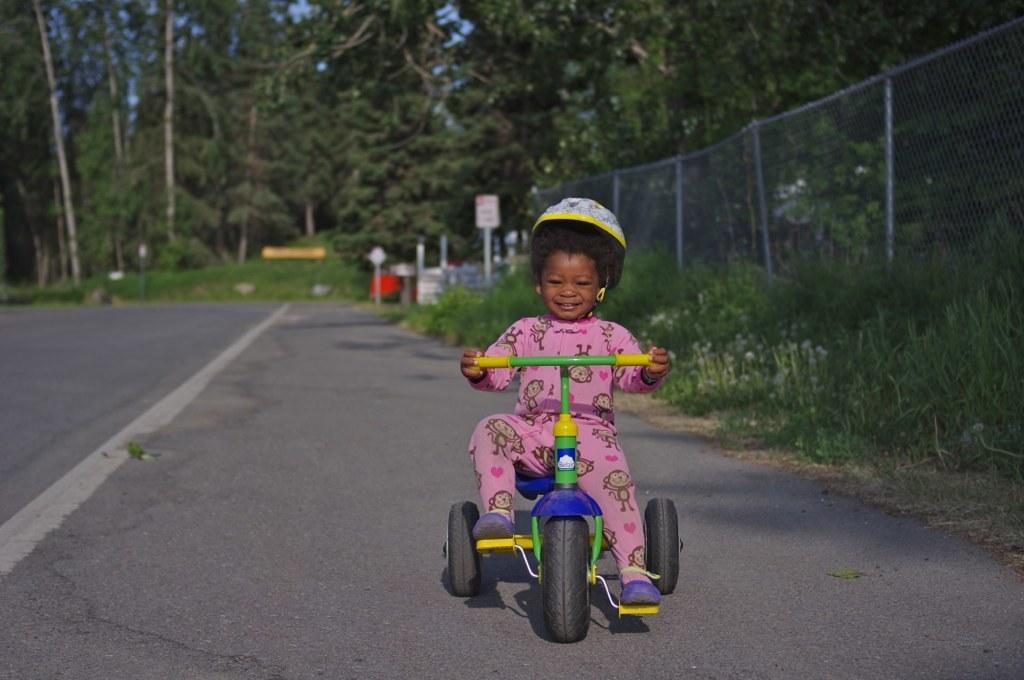How would you summarize this image in a sentence or two? This picture is clicked outside. On the right we can see a kid wearing pink color dress, smiling and riding a bicycle. In the background we can see the trees, mesh, metal rods, plants, grass and some other objects. 